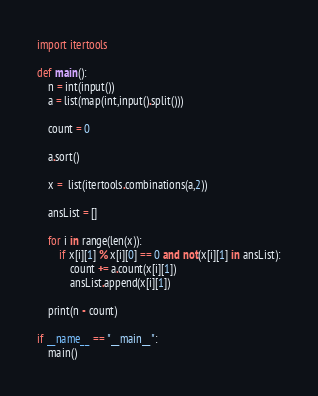Convert code to text. <code><loc_0><loc_0><loc_500><loc_500><_Python_>import itertools

def main():
    n = int(input())
    a = list(map(int,input().split()))

    count = 0

    a.sort()

    x =  list(itertools.combinations(a,2))

    ansList = []
    
    for i in range(len(x)):
        if x[i][1] % x[i][0] == 0 and not(x[i][1] in ansList):
            count += a.count(x[i][1])
            ansList.append(x[i][1])

    print(n - count)

if __name__ == "__main__":
    main()
</code> 